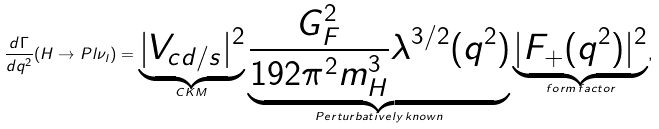Convert formula to latex. <formula><loc_0><loc_0><loc_500><loc_500>\frac { d \Gamma } { d q ^ { 2 } } ( H \to P l \nu _ { l } ) = \underbrace { | V _ { c d / s } | ^ { 2 } } _ { C K M } \underbrace { \frac { G _ { F } ^ { 2 } } { 1 9 2 \pi ^ { 2 } m ^ { 3 } _ { H } } \lambda ^ { 3 / 2 } ( q ^ { 2 } ) } _ { P e r t u r b a t i v e l y \, k n o w n } \underbrace { | F _ { + } ( q ^ { 2 } ) | ^ { 2 } } _ { f o r m \, f a c t o r } ,</formula> 